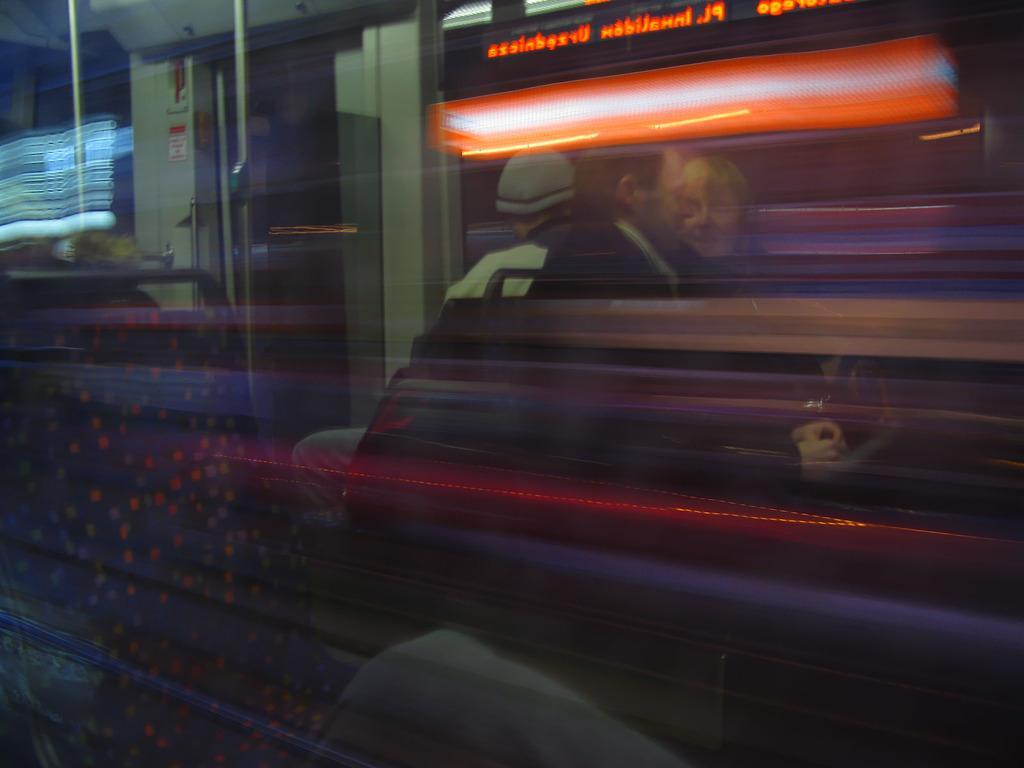Describe this image in one or two sentences. In this image there is a train and we can see people standing in the train. There are lights. 